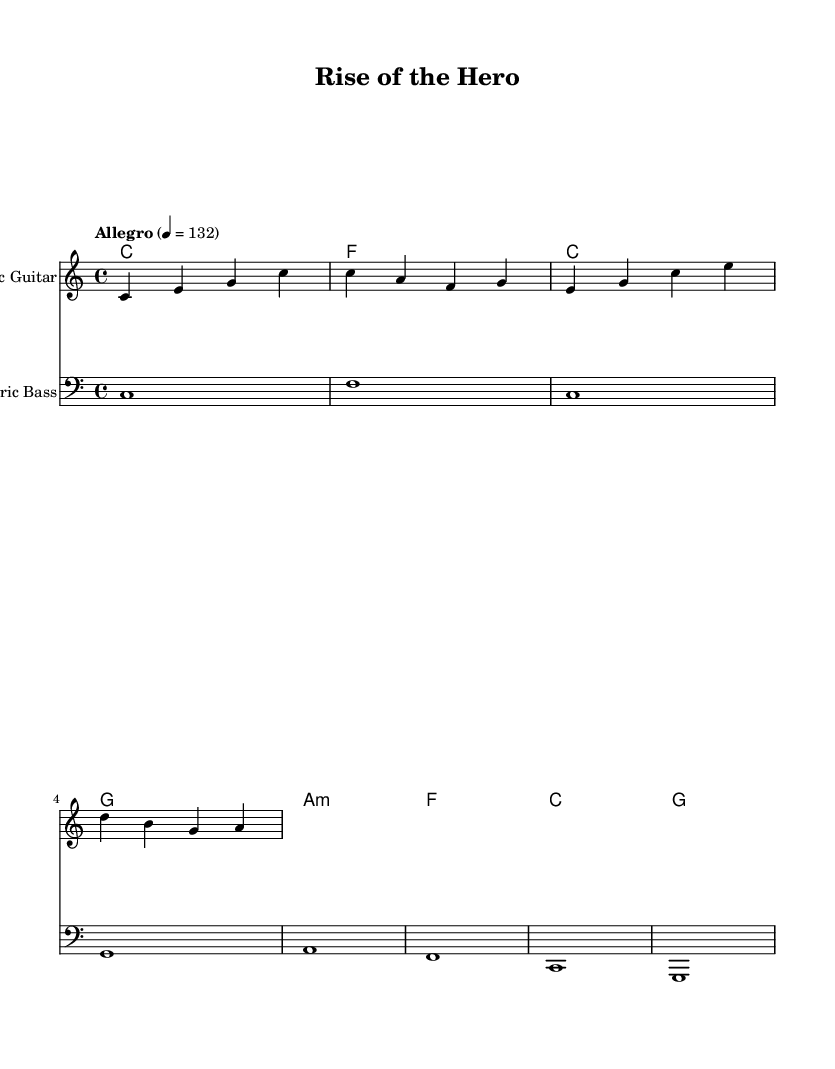What is the key signature of this music? The key signature is C major, which has no sharps or flats.
Answer: C major What is the time signature of this music? The time signature is indicated as 4/4, meaning there are four beats in a measure and the quarter note gets one beat.
Answer: 4/4 What is the tempo marking given in the score? The tempo marking is "Allegro," which indicates a fast and lively pace, specifically set at 132 beats per minute.
Answer: Allegro How many measures are in the melody? The melody consists of 4 measures, each separated by vertical lines. The counting of measures starts from the beginning and stops at the final bar line.
Answer: 4 What instrument plays the melody? The melody is played by the Electric Guitar, as indicated in the staff header notation.
Answer: Electric Guitar Which chord is the first in the harmonies? The first chord indicated in the score is C major, which starts the harmony progression.
Answer: C How many chords are played in total in the harmonies section? There are 7 chords played in total in the score, considering both the distinct harmony and their repetitions within the measures.
Answer: 7 